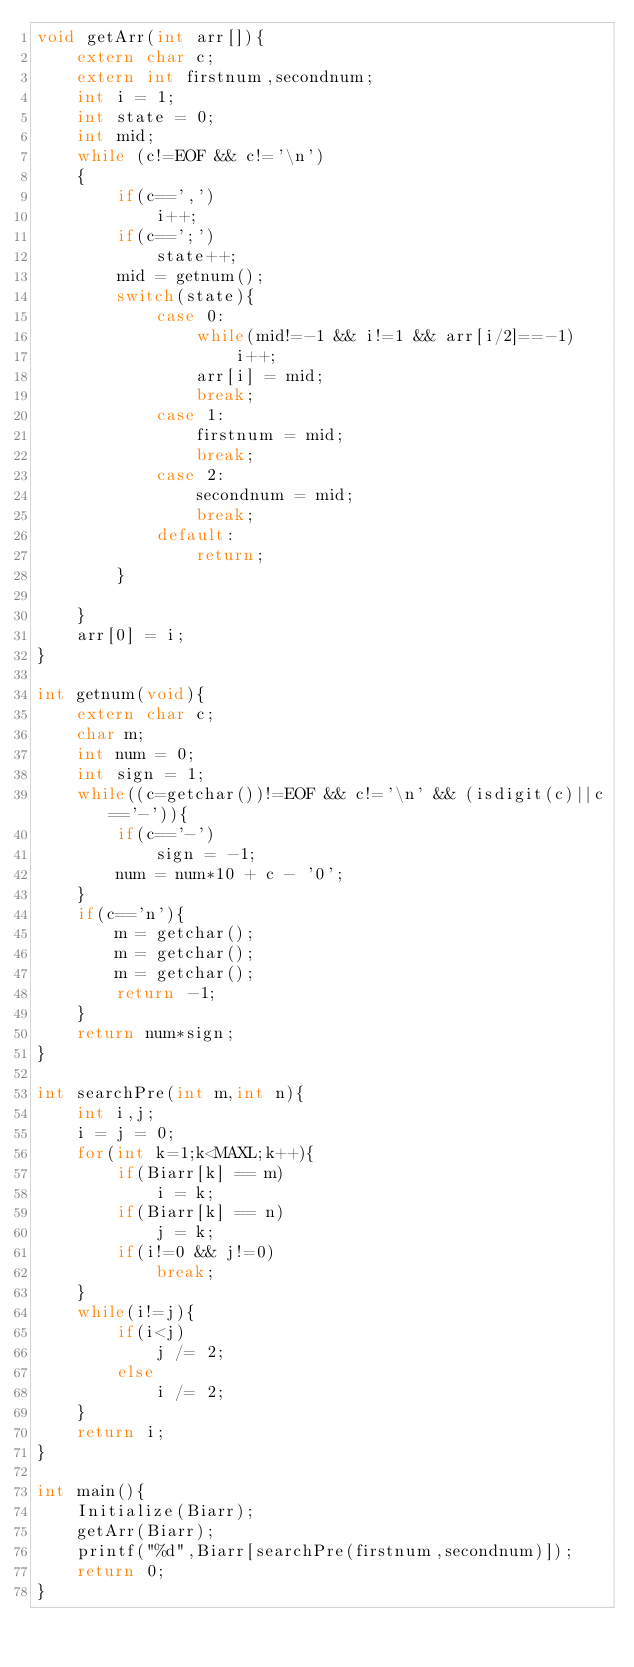<code> <loc_0><loc_0><loc_500><loc_500><_C_>void getArr(int arr[]){
    extern char c;
    extern int firstnum,secondnum;
    int i = 1;
    int state = 0;
    int mid;
    while (c!=EOF && c!='\n')
    {
        if(c==',')
            i++;
        if(c==';')
            state++;
        mid = getnum();
        switch(state){
            case 0:
                while(mid!=-1 && i!=1 && arr[i/2]==-1)
                    i++;
                arr[i] = mid;
                break;
            case 1:
                firstnum = mid;
                break;
            case 2:
                secondnum = mid;
                break;
            default:
                return;
        }
        
    }
    arr[0] = i;
}

int getnum(void){
    extern char c;
    char m;
    int num = 0;
    int sign = 1;
    while((c=getchar())!=EOF && c!='\n' && (isdigit(c)||c=='-')){
        if(c=='-')
            sign = -1;
        num = num*10 + c - '0';
    }
    if(c=='n'){
        m = getchar();
        m = getchar();
        m = getchar();
        return -1;
    }
    return num*sign;
}

int searchPre(int m,int n){
    int i,j;
    i = j = 0;
    for(int k=1;k<MAXL;k++){
        if(Biarr[k] == m)
            i = k;
        if(Biarr[k] == n)
            j = k;
        if(i!=0 && j!=0)
            break;
    }
    while(i!=j){
        if(i<j)
            j /= 2;
        else 
            i /= 2;
    }
    return i;
}

int main(){
    Initialize(Biarr);
    getArr(Biarr);
    printf("%d",Biarr[searchPre(firstnum,secondnum)]);
    return 0;
}
</code> 